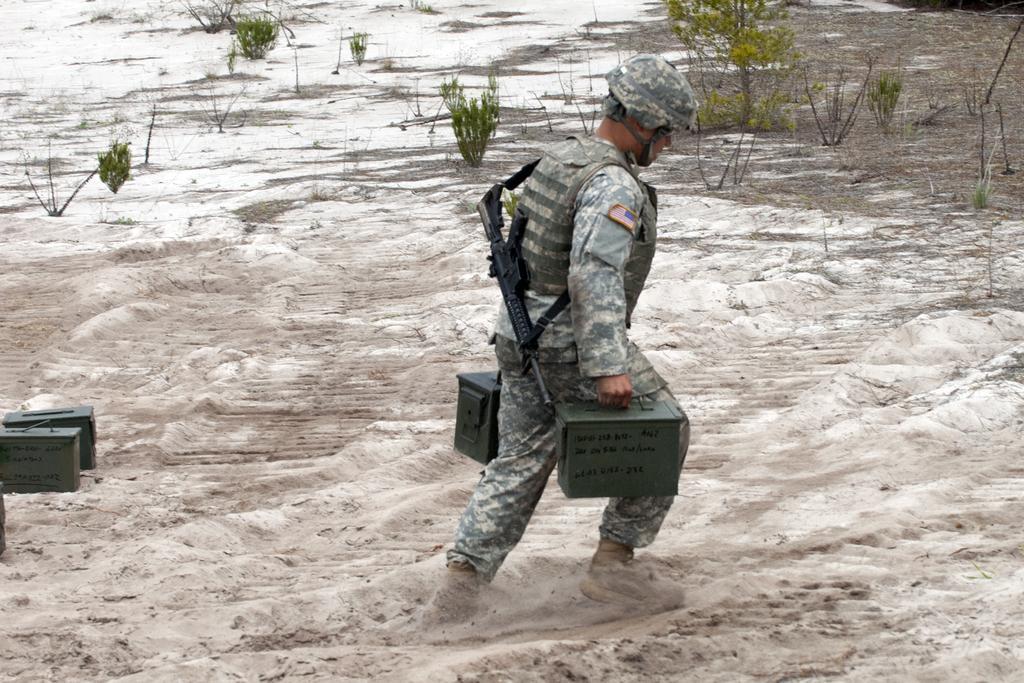In one or two sentences, can you explain what this image depicts? In this image I can see a person walking wearing uniform and gun. The gun is in black color, the person is also holding some object, at the back I can see small plants in green color. 